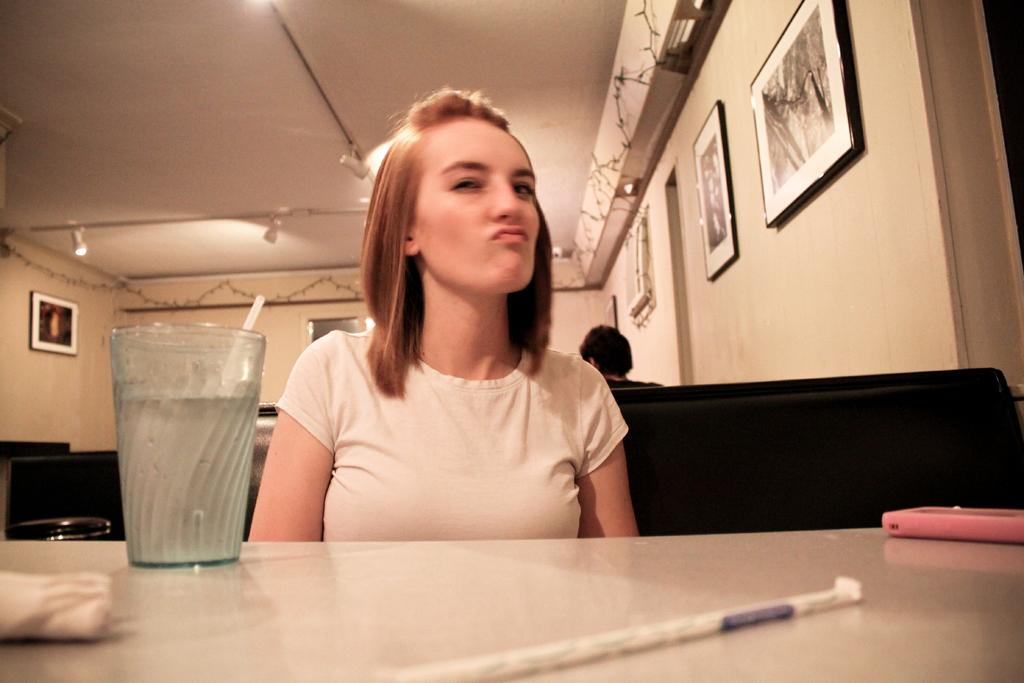What is the woman doing in the image? The woman is sitting behind a table in the image. What objects are on the table with the woman? There is a glass and a phone on the table. What can be seen on the wall in the image? There are photo frames on the wall. What is the source of light in the image? There is a light at the top of the image. What type of ground is visible beneath the woman in the image? There is no ground visible beneath the woman in the image; it appears to be an indoor setting. Is there an oven present in the image? There is no oven present in the image. 